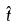Convert formula to latex. <formula><loc_0><loc_0><loc_500><loc_500>\hat { t }</formula> 